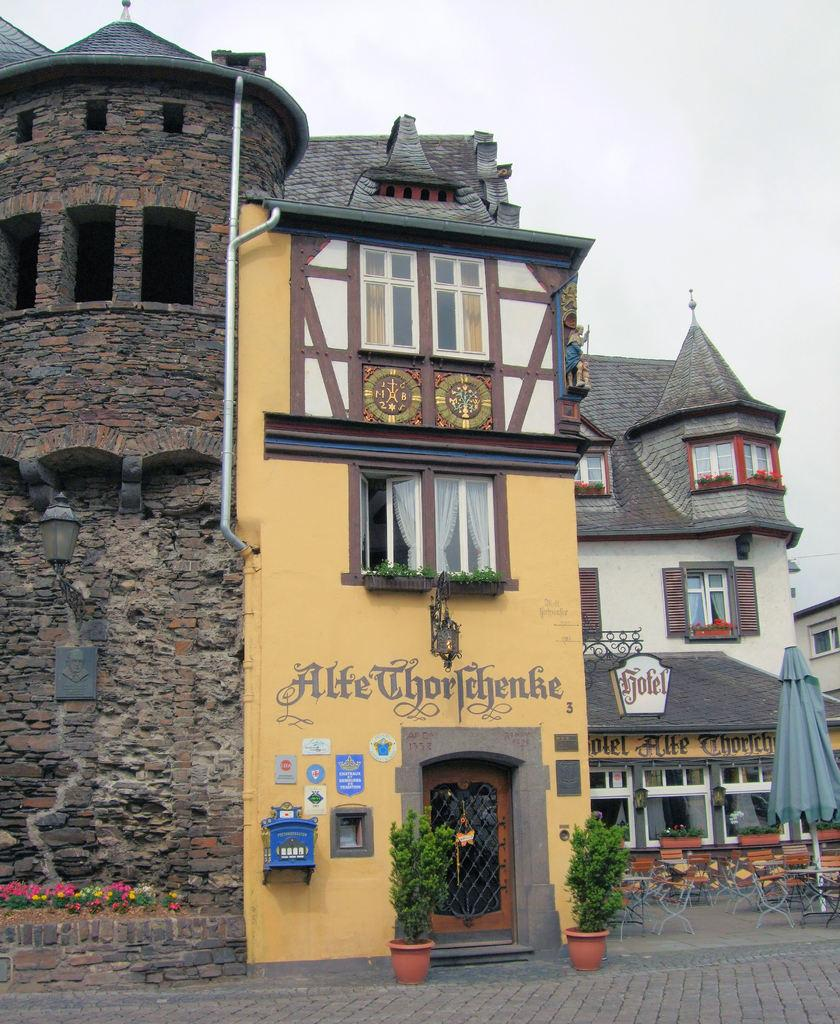What type of structures can be seen in the image? There are buildings in the image. What objects are present in the image that might be used for displaying information? There are boards in the image. What type of vegetation is visible in the image? There are plants in the image. What architectural features can be seen in the buildings? There are windows in the image. What type of decorative elements can be seen in the image? There are flowers in the image. What object is present in the image that might be used for protection from the elements? There is an umbrella in the image. What is visible in the background of the image? The sky is visible in the background of the image. What type of juice can be seen flowing from the umbrella in the image? There is no juice present in the image, and the umbrella is not depicted as leaking or spilling any liquid. What type of power source is visible in the image? There is no power source visible in the image. 